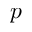<formula> <loc_0><loc_0><loc_500><loc_500>p</formula> 